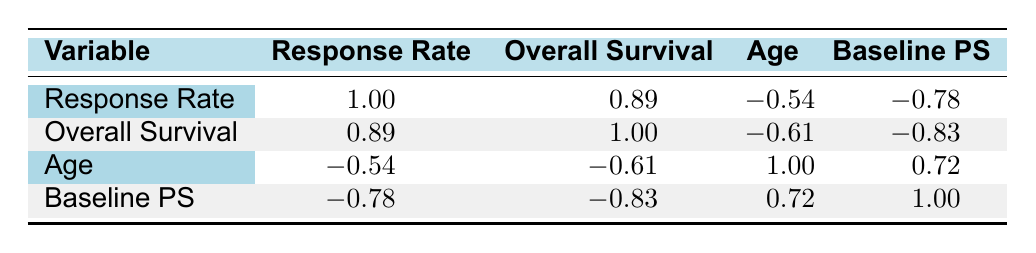What is the correlation between response rate and overall survival? The table indicates a correlation coefficient of 0.89 between response rate and overall survival. This suggests a strong positive correlation, meaning as the response rate increases, overall survival tends to increase as well.
Answer: 0.89 What is the correlation between age and baseline performance status? The table shows a correlation coefficient of 0.72 between age and baseline performance status. This indicates a moderate positive correlation, suggesting that older patients may have higher baseline performance status scores.
Answer: 0.72 Is the correlation between response rate and age negative? The correlation coefficient between response rate and age is -0.54, which is indeed negative. This implies that as age increases, the response rate tends to decrease.
Answer: Yes What is the overall survival of patients with a baseline performance status of 0? The table lists two patients with a baseline performance status of 0: one with an overall survival of 22 months and another with 20 months. Therefore, the overall survival values of these patients are 20 and 22 months.
Answer: 20 and 22 months What is the average correlation coefficient between overall survival and response rate across all trials? The correlation coefficient for overall survival with response rate is listed as 0.89, and no further averages can be calculated since it is the only value given for that relationship. Therefore, the average remains 0.89.
Answer: 0.89 What is the relationship between baseline performance status and overall survival? Looking at the correlation coefficient, we find -0.83, which shows a strong negative correlation. This indicates that as the baseline performance status increases, overall survival tends to decrease.
Answer: -0.83 Are there any patients with a response rate of 0.50 who have a baseline performance status of 2? The data shows that the only patient with a response rate of 0.50 has a baseline performance status of 0, indicating there are no patients who meet the criteria of having a response rate of 0.50 and a baseline performance status of 2.
Answer: No What is the correlation between overall survival and baseline performance status? The correlation coefficient for overall survival and baseline performance status is -0.83. This strong negative correlation suggests that as the baseline performance status increases, overall survival decreases.
Answer: -0.83 How many correlation coefficients are positive in the table? There are three positive correlation coefficients in the table: 0.89 (response rate and overall survival), 0.72 (age and baseline performance status), and 1.00 (response rate with itself).
Answer: 3 